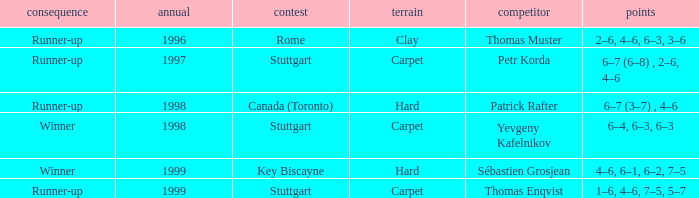What was the surface in 1996? Clay. 